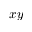<formula> <loc_0><loc_0><loc_500><loc_500>x y</formula> 